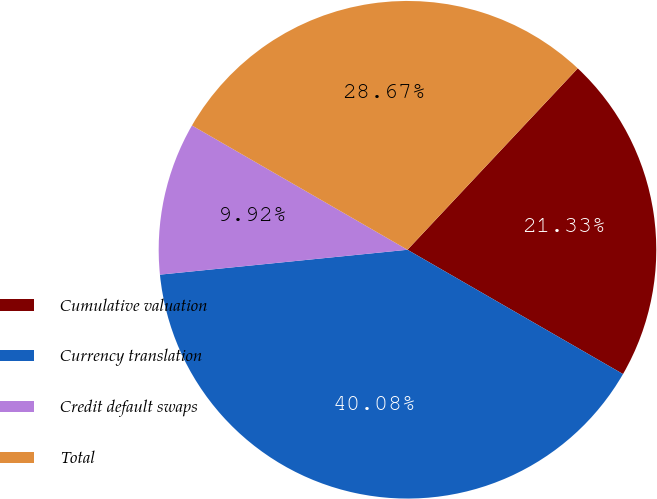Convert chart to OTSL. <chart><loc_0><loc_0><loc_500><loc_500><pie_chart><fcel>Cumulative valuation<fcel>Currency translation<fcel>Credit default swaps<fcel>Total<nl><fcel>21.33%<fcel>40.08%<fcel>9.92%<fcel>28.67%<nl></chart> 